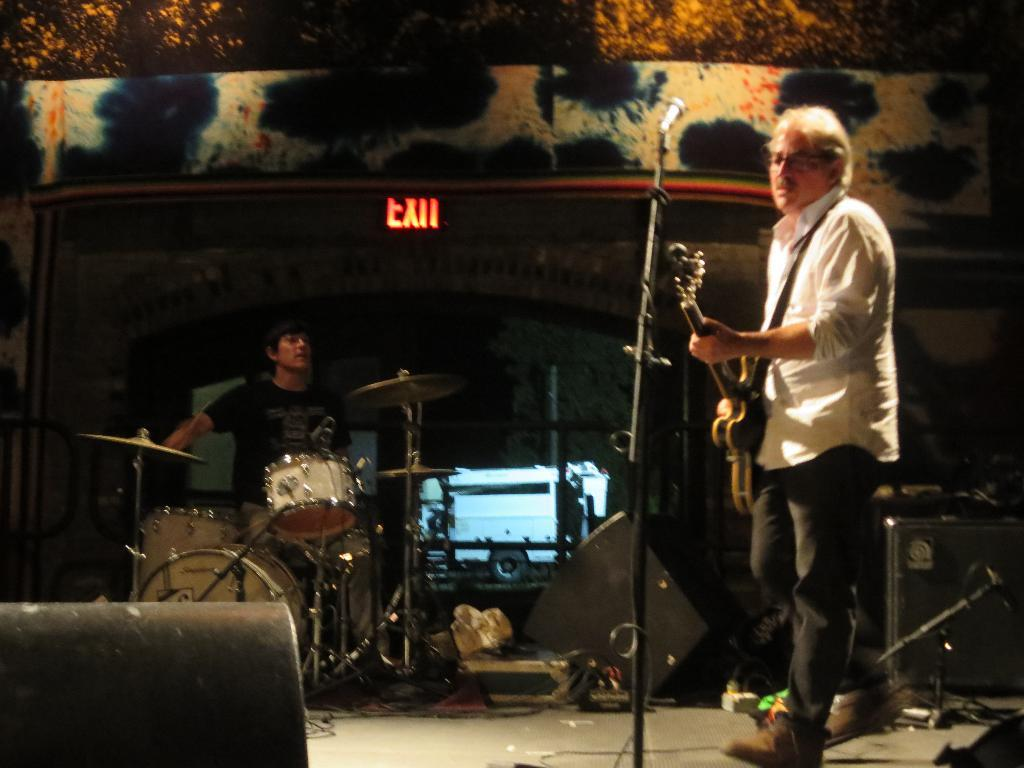What is the man in the image doing? The man is standing in front of a mic and holding a guitar. Who else is present in the image? There is another person in the image. What is the other person doing? The other person is playing an instrument. What is the distance between the man and the payment in the image? There is no mention of payment in the image; it features a man holding a guitar and another person playing an instrument. 